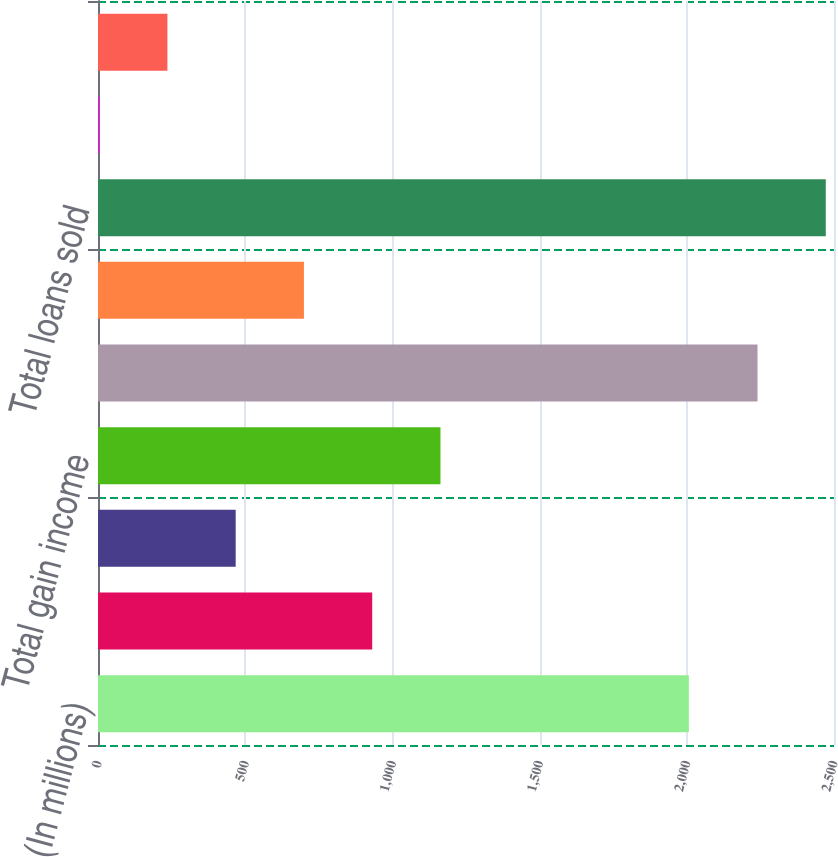Convert chart. <chart><loc_0><loc_0><loc_500><loc_500><bar_chart><fcel>(In millions)<fcel>Gains on sales of loans<fcel>Other gain income<fcel>Total gain income<fcel>Loans originated and sold<fcel>Receivables repurchased from<fcel>Total loans sold<fcel>Gain percentage on loans<fcel>Total gain income as a<nl><fcel>2007<fcel>931.42<fcel>467.66<fcel>1163.3<fcel>2240.2<fcel>699.54<fcel>2472.08<fcel>3.9<fcel>235.78<nl></chart> 